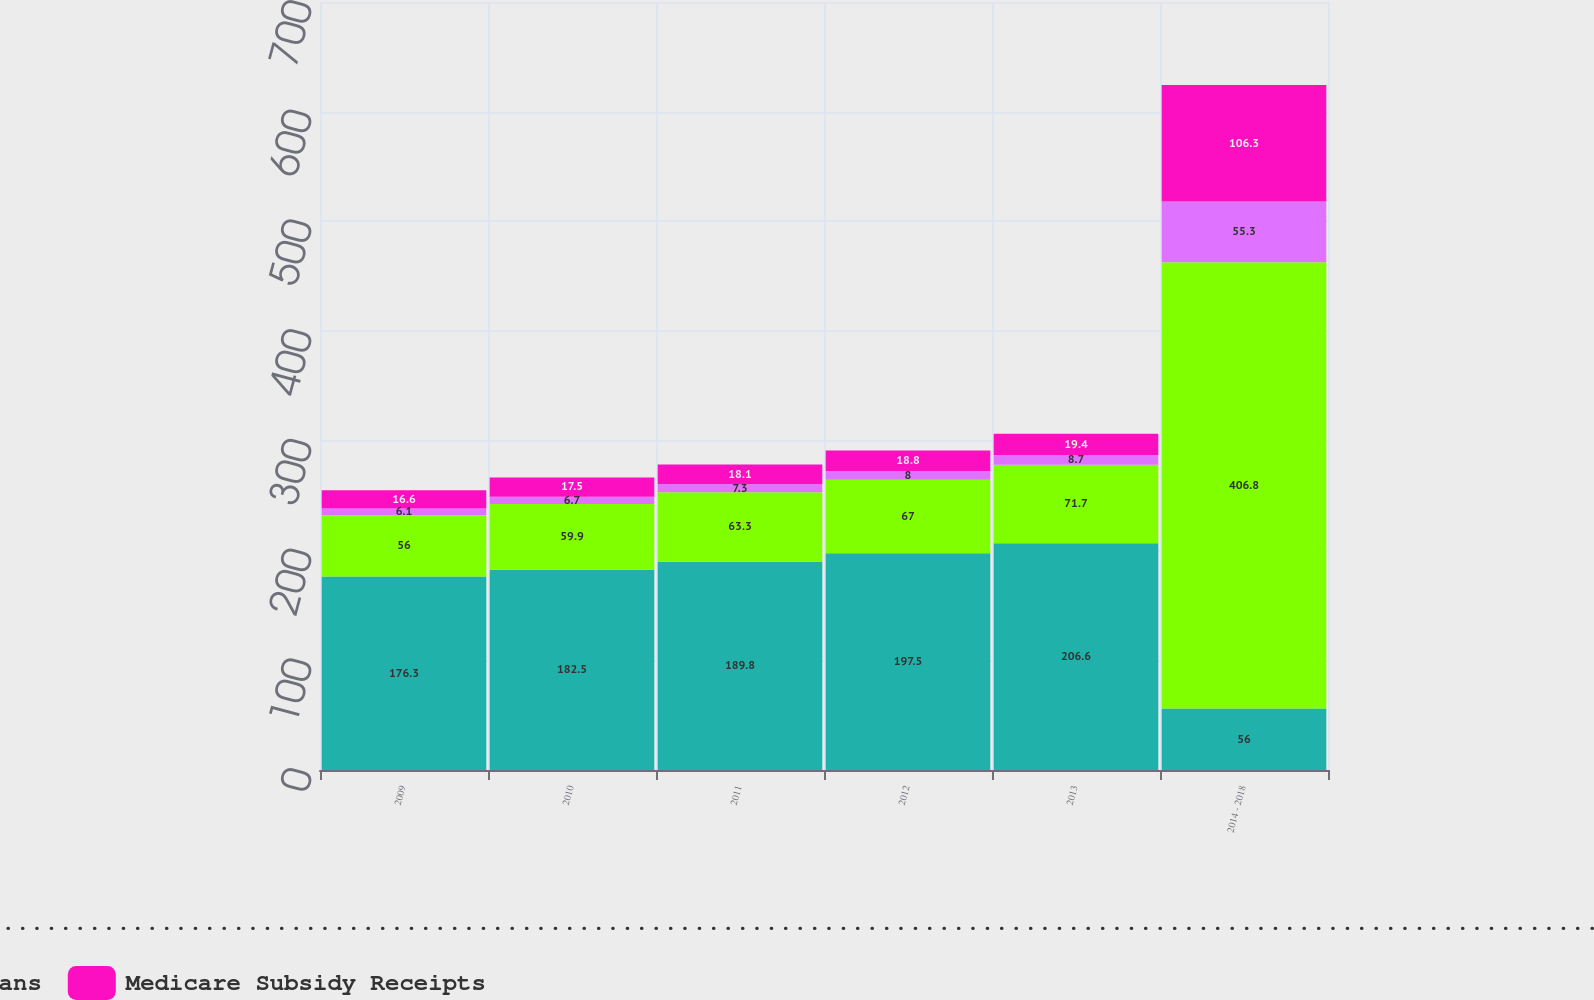Convert chart to OTSL. <chart><loc_0><loc_0><loc_500><loc_500><stacked_bar_chart><ecel><fcel>2009<fcel>2010<fcel>2011<fcel>2012<fcel>2013<fcel>2014 - 2018<nl><fcel>Other Postretirement Benefit Plans Gross Payments .........................................................................................................................................................................................<fcel>176.3<fcel>182.5<fcel>189.8<fcel>197.5<fcel>206.6<fcel>56<nl><fcel>Postemployment Benefit Plans<fcel>56<fcel>59.9<fcel>63.3<fcel>67<fcel>71.7<fcel>406.8<nl><fcel>Defined Benefit Pension Plans<fcel>6.1<fcel>6.7<fcel>7.3<fcel>8<fcel>8.7<fcel>55.3<nl><fcel>Medicare Subsidy Receipts<fcel>16.6<fcel>17.5<fcel>18.1<fcel>18.8<fcel>19.4<fcel>106.3<nl></chart> 